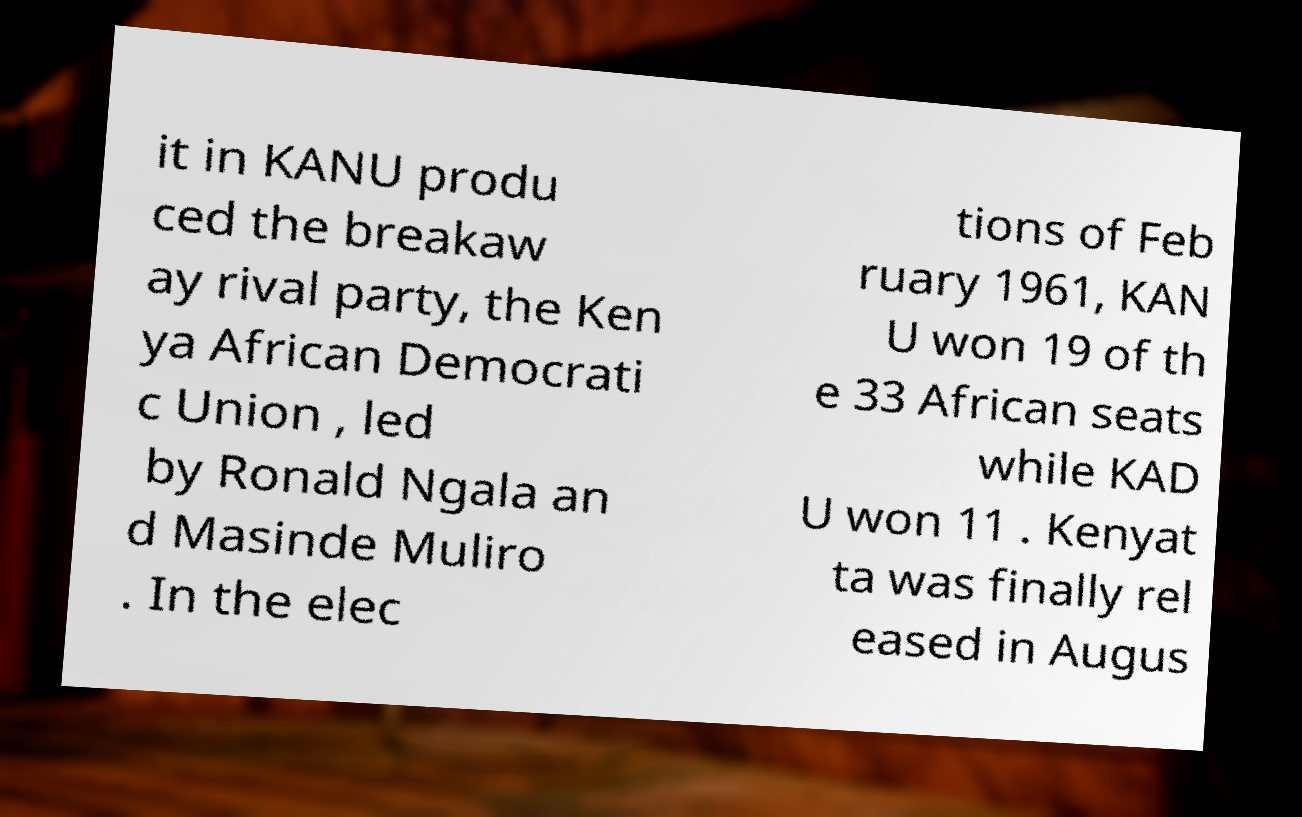What messages or text are displayed in this image? I need them in a readable, typed format. it in KANU produ ced the breakaw ay rival party, the Ken ya African Democrati c Union , led by Ronald Ngala an d Masinde Muliro . In the elec tions of Feb ruary 1961, KAN U won 19 of th e 33 African seats while KAD U won 11 . Kenyat ta was finally rel eased in Augus 